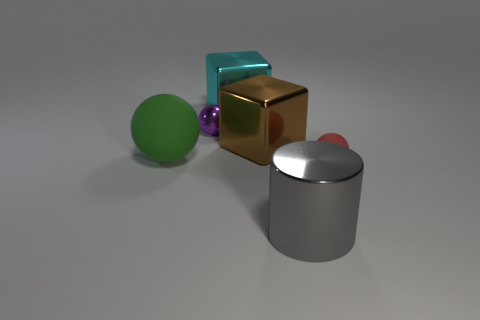Subtract all matte spheres. How many spheres are left? 1 Add 1 big cyan metal things. How many objects exist? 7 Subtract all cubes. How many objects are left? 4 Subtract 1 cylinders. How many cylinders are left? 0 Subtract all purple spheres. How many spheres are left? 2 Subtract all brown cylinders. Subtract all gray blocks. How many cylinders are left? 1 Subtract all purple cylinders. How many red balls are left? 1 Subtract all purple shiny spheres. Subtract all big blue matte things. How many objects are left? 5 Add 5 metal cylinders. How many metal cylinders are left? 6 Add 1 large rubber cylinders. How many large rubber cylinders exist? 1 